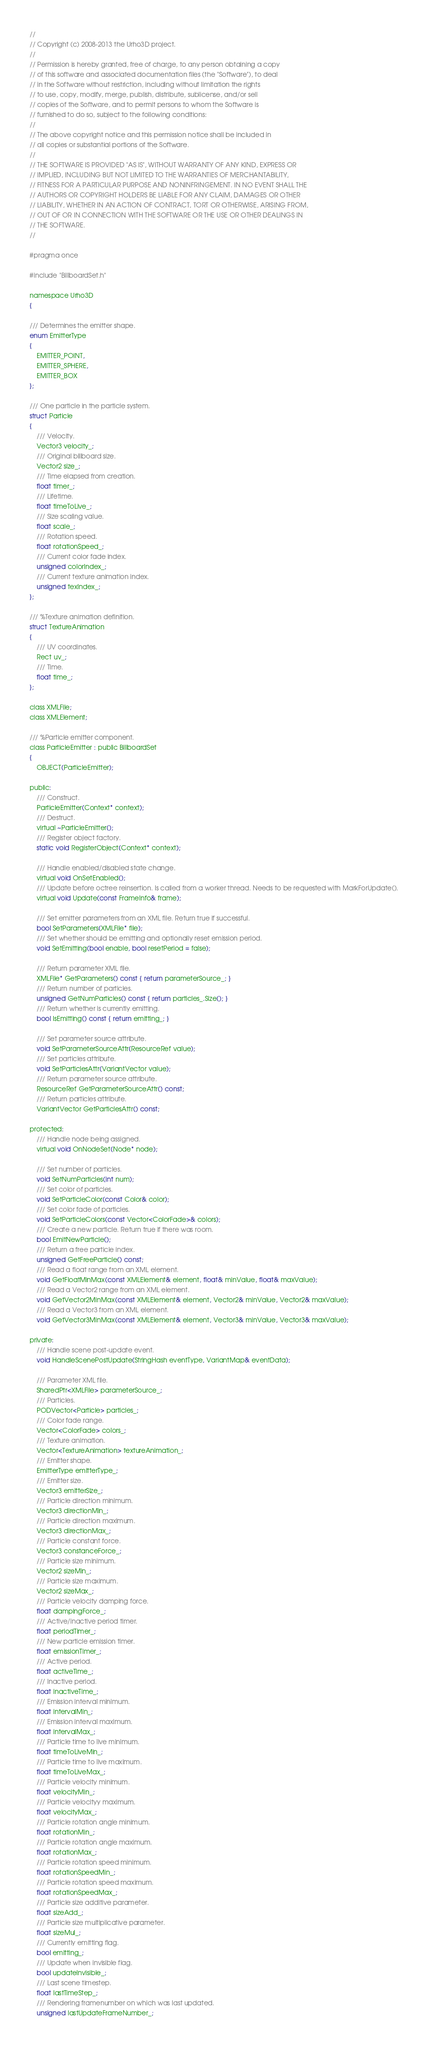<code> <loc_0><loc_0><loc_500><loc_500><_C_>//
// Copyright (c) 2008-2013 the Urho3D project.
//
// Permission is hereby granted, free of charge, to any person obtaining a copy
// of this software and associated documentation files (the "Software"), to deal
// in the Software without restriction, including without limitation the rights
// to use, copy, modify, merge, publish, distribute, sublicense, and/or sell
// copies of the Software, and to permit persons to whom the Software is
// furnished to do so, subject to the following conditions:
//
// The above copyright notice and this permission notice shall be included in
// all copies or substantial portions of the Software.
//
// THE SOFTWARE IS PROVIDED "AS IS", WITHOUT WARRANTY OF ANY KIND, EXPRESS OR
// IMPLIED, INCLUDING BUT NOT LIMITED TO THE WARRANTIES OF MERCHANTABILITY,
// FITNESS FOR A PARTICULAR PURPOSE AND NONINFRINGEMENT. IN NO EVENT SHALL THE
// AUTHORS OR COPYRIGHT HOLDERS BE LIABLE FOR ANY CLAIM, DAMAGES OR OTHER
// LIABILITY, WHETHER IN AN ACTION OF CONTRACT, TORT OR OTHERWISE, ARISING FROM,
// OUT OF OR IN CONNECTION WITH THE SOFTWARE OR THE USE OR OTHER DEALINGS IN
// THE SOFTWARE.
//

#pragma once

#include "BillboardSet.h"

namespace Urho3D
{

/// Determines the emitter shape.
enum EmitterType
{
    EMITTER_POINT,
    EMITTER_SPHERE,
    EMITTER_BOX
};

/// One particle in the particle system.
struct Particle
{
    /// Velocity.
    Vector3 velocity_;
    /// Original billboard size.
    Vector2 size_;
    /// Time elapsed from creation.
    float timer_;
    /// Lifetime.
    float timeToLive_;
    /// Size scaling value.
    float scale_;
    /// Rotation speed.
    float rotationSpeed_;
    /// Current color fade index.
    unsigned colorIndex_;
    /// Current texture animation index.
    unsigned texIndex_;
};

/// %Texture animation definition.
struct TextureAnimation
{
    /// UV coordinates.
    Rect uv_;
    /// Time.
    float time_;
};

class XMLFile;
class XMLElement;

/// %Particle emitter component.
class ParticleEmitter : public BillboardSet
{
    OBJECT(ParticleEmitter);
    
public:
    /// Construct.
    ParticleEmitter(Context* context);
    /// Destruct.
    virtual ~ParticleEmitter();
    /// Register object factory.
    static void RegisterObject(Context* context);
    
    /// Handle enabled/disabled state change.
    virtual void OnSetEnabled();
    /// Update before octree reinsertion. Is called from a worker thread. Needs to be requested with MarkForUpdate().
    virtual void Update(const FrameInfo& frame);
    
    /// Set emitter parameters from an XML file. Return true if successful.
    bool SetParameters(XMLFile* file);
    /// Set whether should be emitting and optionally reset emission period.
    void SetEmitting(bool enable, bool resetPeriod = false);
    
    /// Return parameter XML file.
    XMLFile* GetParameters() const { return parameterSource_; }
    /// Return number of particles.
    unsigned GetNumParticles() const { return particles_.Size(); }
    /// Return whether is currently emitting.
    bool IsEmitting() const { return emitting_; }
    
    /// Set parameter source attribute.
    void SetParameterSourceAttr(ResourceRef value);
    /// Set particles attribute.
    void SetParticlesAttr(VariantVector value);
    /// Return parameter source attribute.
    ResourceRef GetParameterSourceAttr() const;
    /// Return particles attribute.
    VariantVector GetParticlesAttr() const;
    
protected:
    /// Handle node being assigned.
    virtual void OnNodeSet(Node* node);
    
    /// Set number of particles.
    void SetNumParticles(int num);
    /// Set color of particles.
    void SetParticleColor(const Color& color);
    /// Set color fade of particles.
    void SetParticleColors(const Vector<ColorFade>& colors);
    /// Create a new particle. Return true if there was room.
    bool EmitNewParticle();
    /// Return a free particle index.
    unsigned GetFreeParticle() const;
    /// Read a float range from an XML element.
    void GetFloatMinMax(const XMLElement& element, float& minValue, float& maxValue);
    /// Read a Vector2 range from an XML element.
    void GetVector2MinMax(const XMLElement& element, Vector2& minValue, Vector2& maxValue);
    /// Read a Vector3 from an XML element.
    void GetVector3MinMax(const XMLElement& element, Vector3& minValue, Vector3& maxValue);
    
private:
    /// Handle scene post-update event.
    void HandleScenePostUpdate(StringHash eventType, VariantMap& eventData);
    
    /// Parameter XML file.
    SharedPtr<XMLFile> parameterSource_;
    /// Particles.
    PODVector<Particle> particles_;
    /// Color fade range.
    Vector<ColorFade> colors_;
    /// Texture animation.
    Vector<TextureAnimation> textureAnimation_;
    /// Emitter shape.
    EmitterType emitterType_;
    /// Emitter size.
    Vector3 emitterSize_;
    /// Particle direction minimum.
    Vector3 directionMin_;
    /// Particle direction maximum.
    Vector3 directionMax_;
    /// Particle constant force.
    Vector3 constanceForce_;
    /// Particle size minimum.
    Vector2 sizeMin_;
    /// Particle size maximum.
    Vector2 sizeMax_;
    /// Particle velocity damping force.
    float dampingForce_;
    /// Active/inactive period timer.
    float periodTimer_;
    /// New particle emission timer.
    float emissionTimer_;
    /// Active period.
    float activeTime_;
    /// Inactive period.
    float inactiveTime_;
    /// Emission interval minimum.
    float intervalMin_;
    /// Emission interval maximum.
    float intervalMax_;
    /// Particle time to live minimum.
    float timeToLiveMin_;
    /// Particle time to live maximum.
    float timeToLiveMax_;
    /// Particle velocity minimum.
    float velocityMin_;
    /// Particle velocityy maximum.
    float velocityMax_;
    /// Particle rotation angle minimum.
    float rotationMin_;
    /// Particle rotation angle maximum.
    float rotationMax_;
    /// Particle rotation speed minimum.
    float rotationSpeedMin_;
    /// Particle rotation speed maximum.
    float rotationSpeedMax_;
    /// Particle size additive parameter.
    float sizeAdd_;
    /// Particle size multiplicative parameter.
    float sizeMul_;
    /// Currently emitting flag.
    bool emitting_;
    /// Update when invisible flag.
    bool updateInvisible_;
    /// Last scene timestep.
    float lastTimeStep_;
    /// Rendering framenumber on which was last updated.
    unsigned lastUpdateFrameNumber_;</code> 